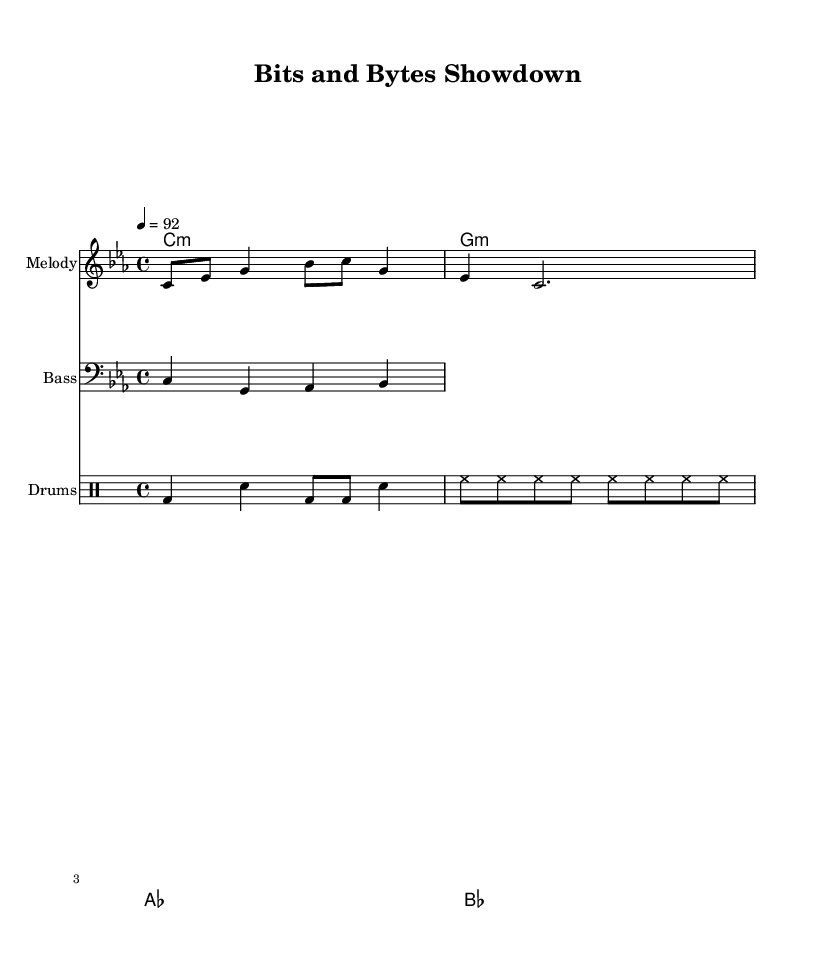What is the key signature of this music? The key signature indicates the piece is in C minor, which typically includes three flats (B flat, E flat, and A flat). Since the score indicates C minor with no sharps or additional alterations noted, it confirms the key signature.
Answer: C minor What is the time signature of the piece? The time signature is indicated at the beginning of the score as 4/4, which means there are four beats in each measure and the quarter note receives one beat. This can be observed in the rhythmic layout of the melody and drum pattern.
Answer: 4/4 What is the tempo marking in this music? The tempo marking is shown as "4 = 92," which indicates that there are 92 beats per minute, with each quarter note receiving one beat. This is conveyed at the beginning of the score, directly influencing how fast the piece should be played.
Answer: 92 How many measures are in the melody section? The melody section contains four measures, which can be counted by observing the bars (vertical lines) separating each group of notes in the melody staff. Each grouping of notes between two bar lines represents one measure, thus leading to the total count.
Answer: 4 What is the lyric that starts with "Punching cards"? The lyric associated with the melody starts with "Punching cards and breaking codes," which can be found directly below the notes in the lyrics section of the sheet music. This is a specific line from the lyrics written in the Lyric mode.
Answer: Punching cards and breaking codes Which chord is played during the first measure? The first measure features the chord C minor, as indicated in the chord names section located at the beginning of every measure, where the abbreviation "c1:m" denotes that chord. This clearly outlines which chord should be played while accompanying the melody.
Answer: C minor Who is referred to in the lyric "I'm the mother of all programmers"? The lyric "I'm the mother of all programmers, yo!" references Grace Hopper, who is often celebrated as a pioneering figure in computer programming. This line emphasizes her significance in the rap, connecting the content to a historical figure in computing.
Answer: Grace Hopper 